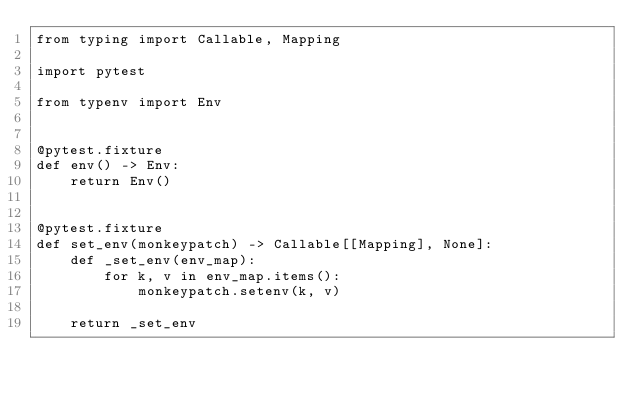<code> <loc_0><loc_0><loc_500><loc_500><_Python_>from typing import Callable, Mapping

import pytest

from typenv import Env


@pytest.fixture
def env() -> Env:
    return Env()


@pytest.fixture
def set_env(monkeypatch) -> Callable[[Mapping], None]:
    def _set_env(env_map):
        for k, v in env_map.items():
            monkeypatch.setenv(k, v)

    return _set_env
</code> 